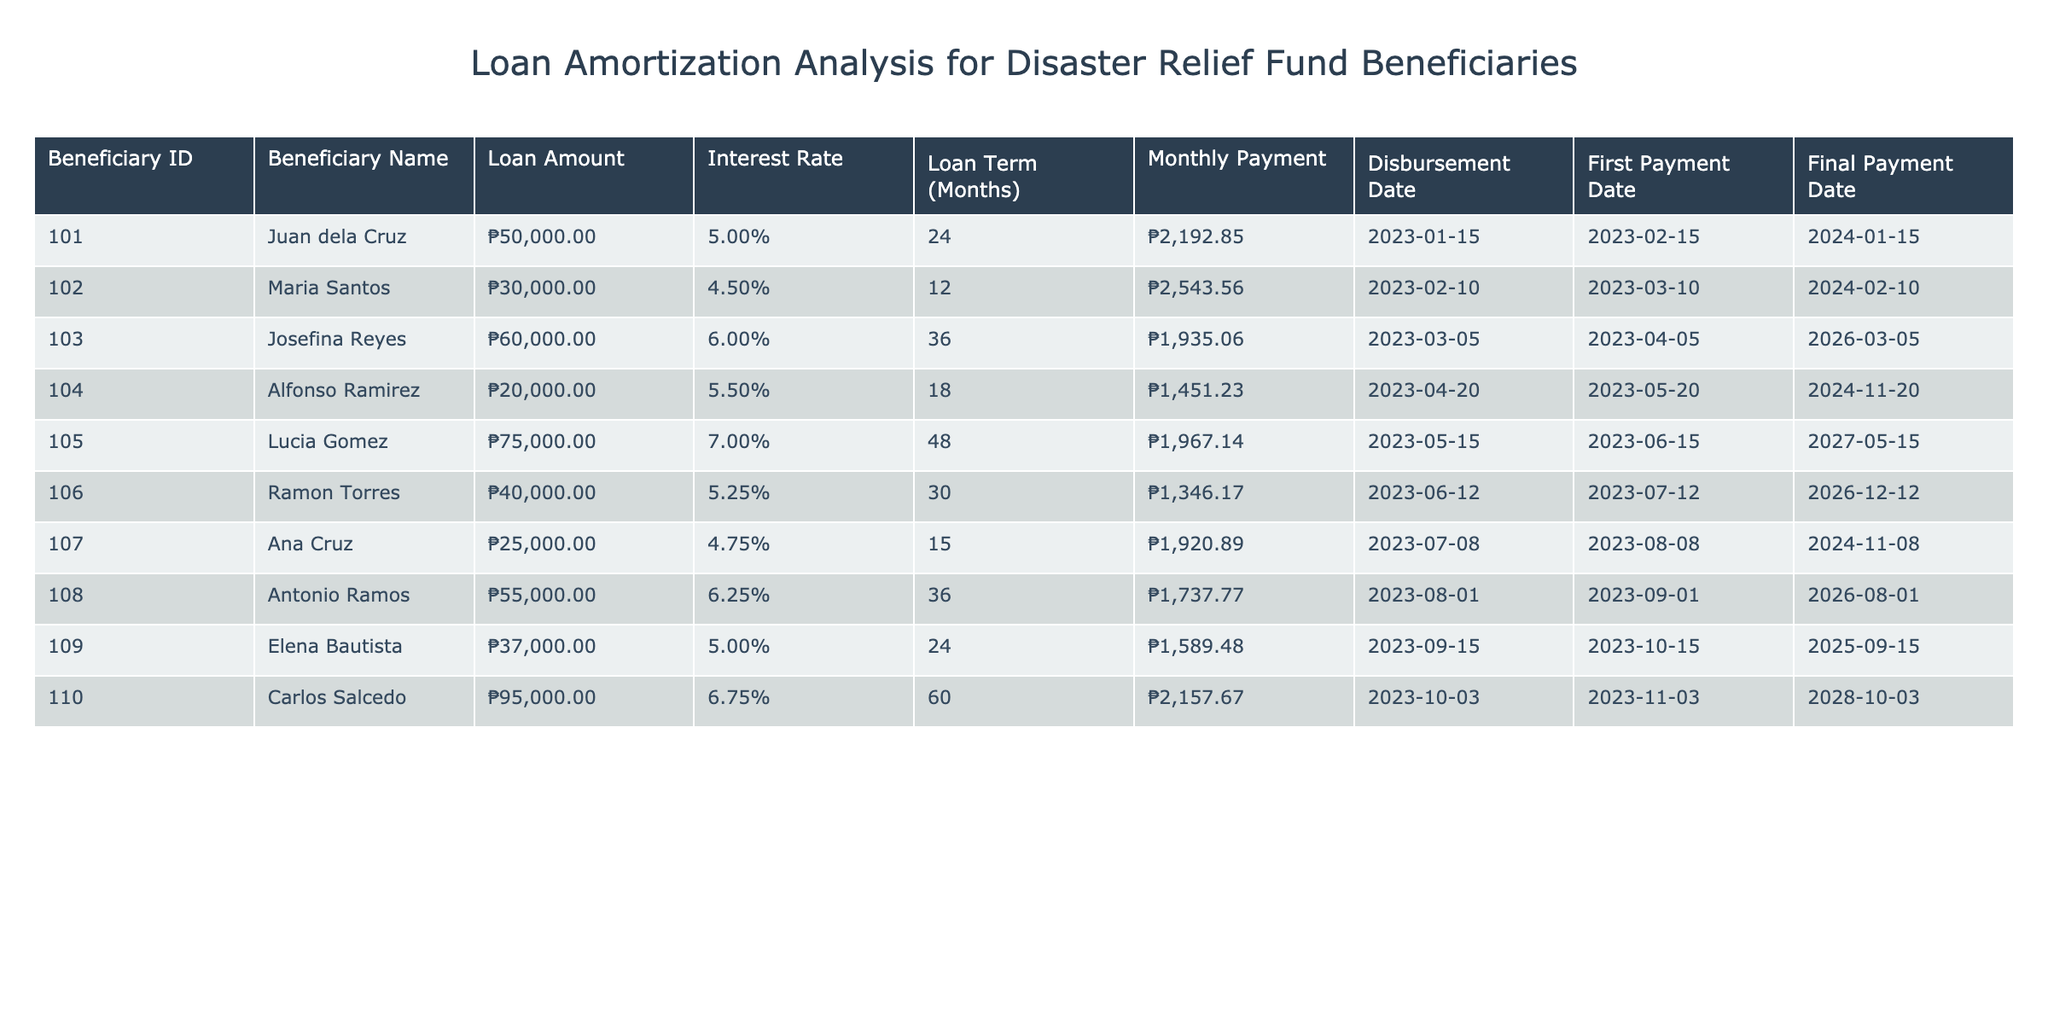What is the loan amount for Juan dela Cruz? The table lists Juan dela Cruz under Beneficiary ID 101, and the Loan Amount column shows ₱50,000.
Answer: ₱50,000 How many months is the loan term for Maria Santos? Maria Santos is listed under Beneficiary ID 102, with a Loan Term (Months) of 12 in the table.
Answer: 12 months What is the average monthly payment for all beneficiaries? To find the average, we sum the monthly payments: 2192.85 + 2543.56 + 1935.06 + 1451.23 + 1967.14 + 1346.17 + 1920.89 + 1737.77 + 1589.48 + 2157.67 =  19,135.81. There are 10 beneficiaries, so the average is 19135.81 / 10 = 1913.58.
Answer: ₱1,913.58 Did any beneficiary have a loan amount greater than ₱70,000? By reviewing the Loan Amount column, it is clear that Lucia Gomez had a Loan Amount of ₱75,000, confirming that yes, at least one beneficiary had a loan greater than ₱70,000.
Answer: Yes What is the difference in monthly payment between the highest and lowest loan amounts? The highest loan amount is ₱95,000 (Carlos Salcedo) with a monthly payment of ₱2,157.67. The lowest loan amount is ₱20,000 (Alfonso Ramirez) with a monthly payment of ₱1,451.23. The difference in their monthly payments is ₱2,157.67 - ₱1,451.23 = ₱706.44.
Answer: ₱706.44 When is the first payment date for the beneficiary with the highest interest rate? The beneficiary with the highest interest rate is Carlos Salcedo (6.75%) listed under Beneficiary ID 110. His First Payment Date is 2023-11-03 according to the table.
Answer: 2023-11-03 What is the total loan amount across all beneficiaries? Adding up the Loan Amounts: 50000 + 30000 + 60000 + 20000 + 75000 + 40000 + 25000 + 55000 + 37000 + 95000 = 385,000. Thus, the total loan amount provided to all beneficiaries is ₱385,000.
Answer: ₱385,000 Which beneficiary has the longest loan term and what is that term? Josefina Reyes has the longest loan term of 36 months as indicated in the Loan Term (Months) column under Beneficiary ID 103, making it the maximum term among all listed.
Answer: 36 months What percentage of the total loan amount is allocated to Ana Cruz? The loan amount for Ana Cruz is ₱25,000. The total loan amount across all beneficiaries is ₱385,000. To find the percentage: (25000 / 385000) * 100 = 6.49%.
Answer: 6.49% 